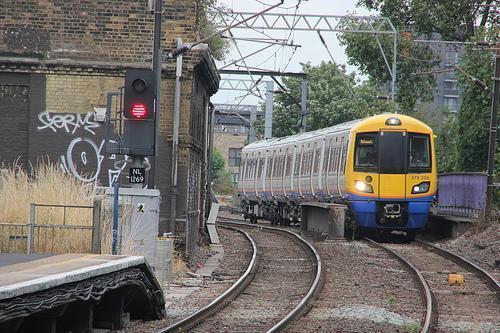How many pairs of tracks are there?
Give a very brief answer. 2. 